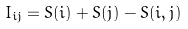Convert formula to latex. <formula><loc_0><loc_0><loc_500><loc_500>I _ { i j } = S ( i ) + S ( j ) - S ( i , j )</formula> 